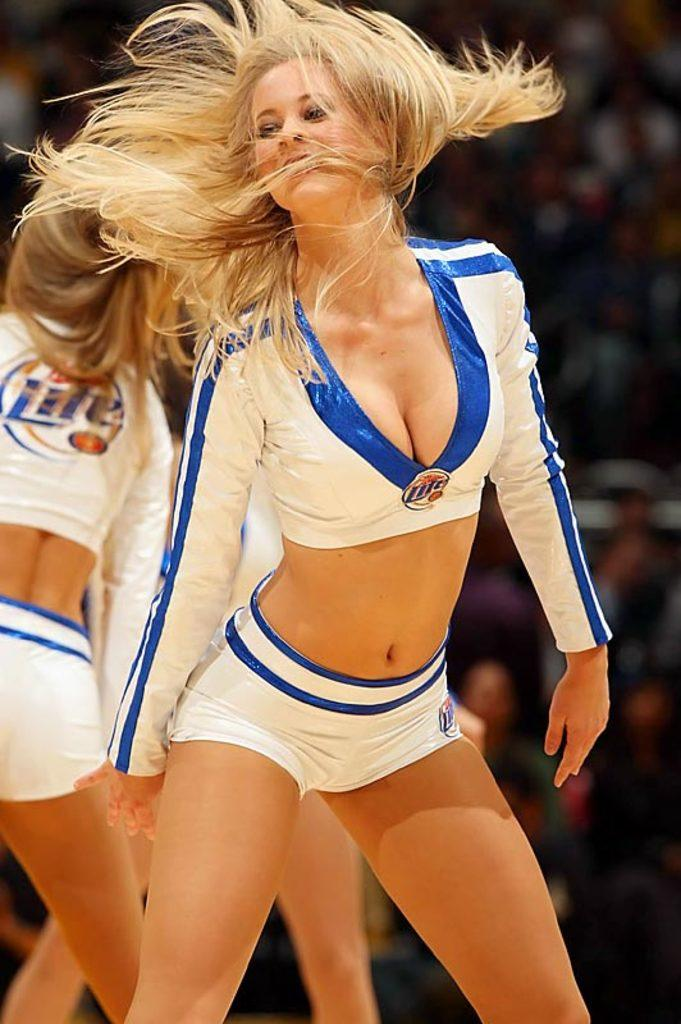<image>
Summarize the visual content of the image. Dancers wearing white have a logo attached that says Lite. 